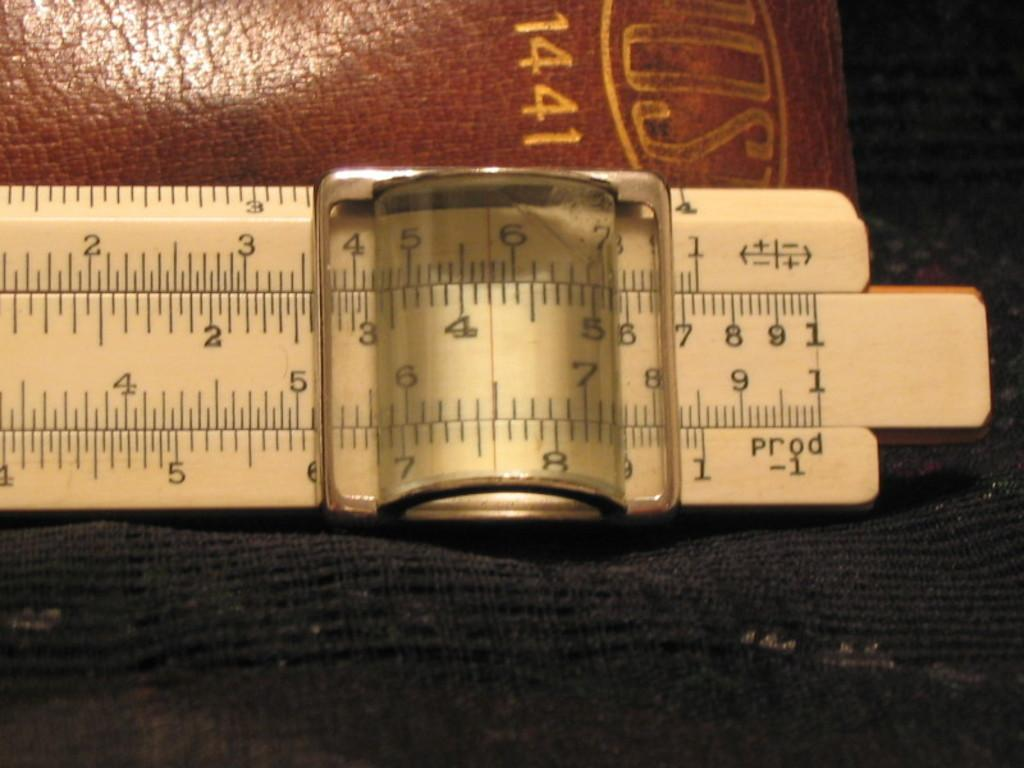<image>
Present a compact description of the photo's key features. Wooden ruler with numbers and measurements going from 1 to 5. 